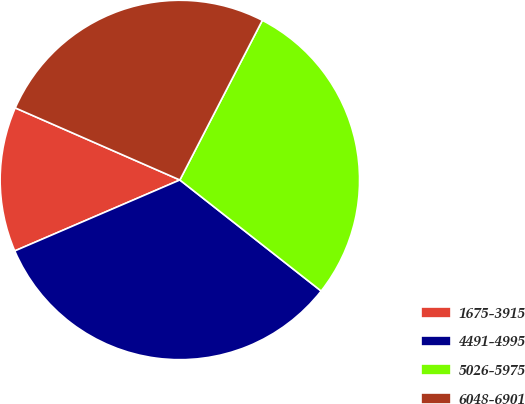<chart> <loc_0><loc_0><loc_500><loc_500><pie_chart><fcel>1675-3915<fcel>4491-4995<fcel>5026-5975<fcel>6048-6901<nl><fcel>13.03%<fcel>32.94%<fcel>28.01%<fcel>26.02%<nl></chart> 